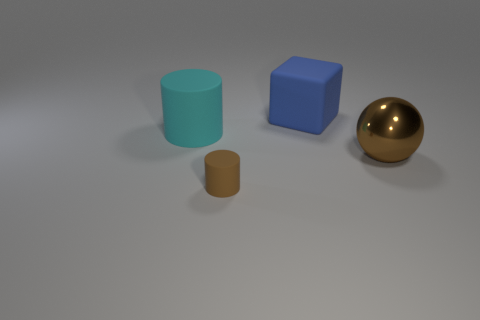Are there any other things that have the same size as the brown matte cylinder?
Keep it short and to the point. No. How many other things are there of the same shape as the brown rubber thing?
Make the answer very short. 1. The large thing that is both in front of the blue matte block and on the left side of the metallic sphere has what shape?
Ensure brevity in your answer.  Cylinder. What color is the cylinder in front of the brown object behind the matte cylinder to the right of the cyan cylinder?
Your response must be concise. Brown. Is the number of matte cylinders that are in front of the sphere greater than the number of big blue matte blocks that are behind the blue rubber object?
Offer a terse response. Yes. What number of other objects are the same size as the blue rubber block?
Provide a short and direct response. 2. There is another metal object that is the same color as the small thing; what size is it?
Your answer should be very brief. Large. There is a cylinder that is in front of the big object to the right of the blue rubber block; what is it made of?
Offer a terse response. Rubber. Are there any rubber cylinders behind the big brown object?
Your response must be concise. Yes. Are there more brown things that are in front of the shiny ball than large cyan shiny balls?
Offer a very short reply. Yes. 